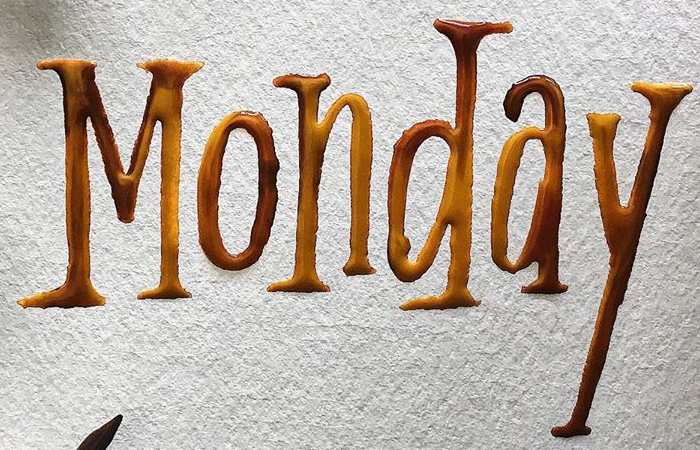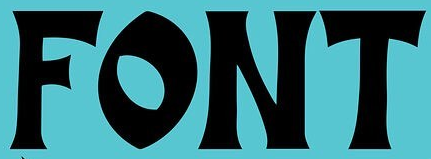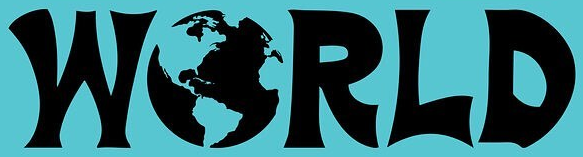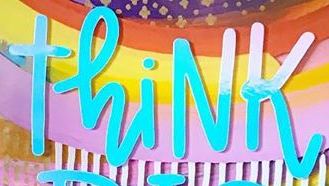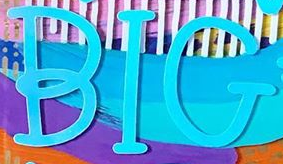Identify the words shown in these images in order, separated by a semicolon. Monday; FONT; WORLD; ThiNK; BIG 